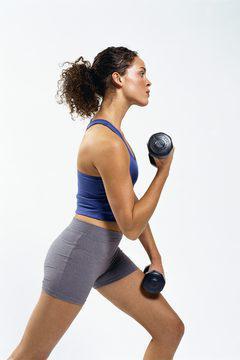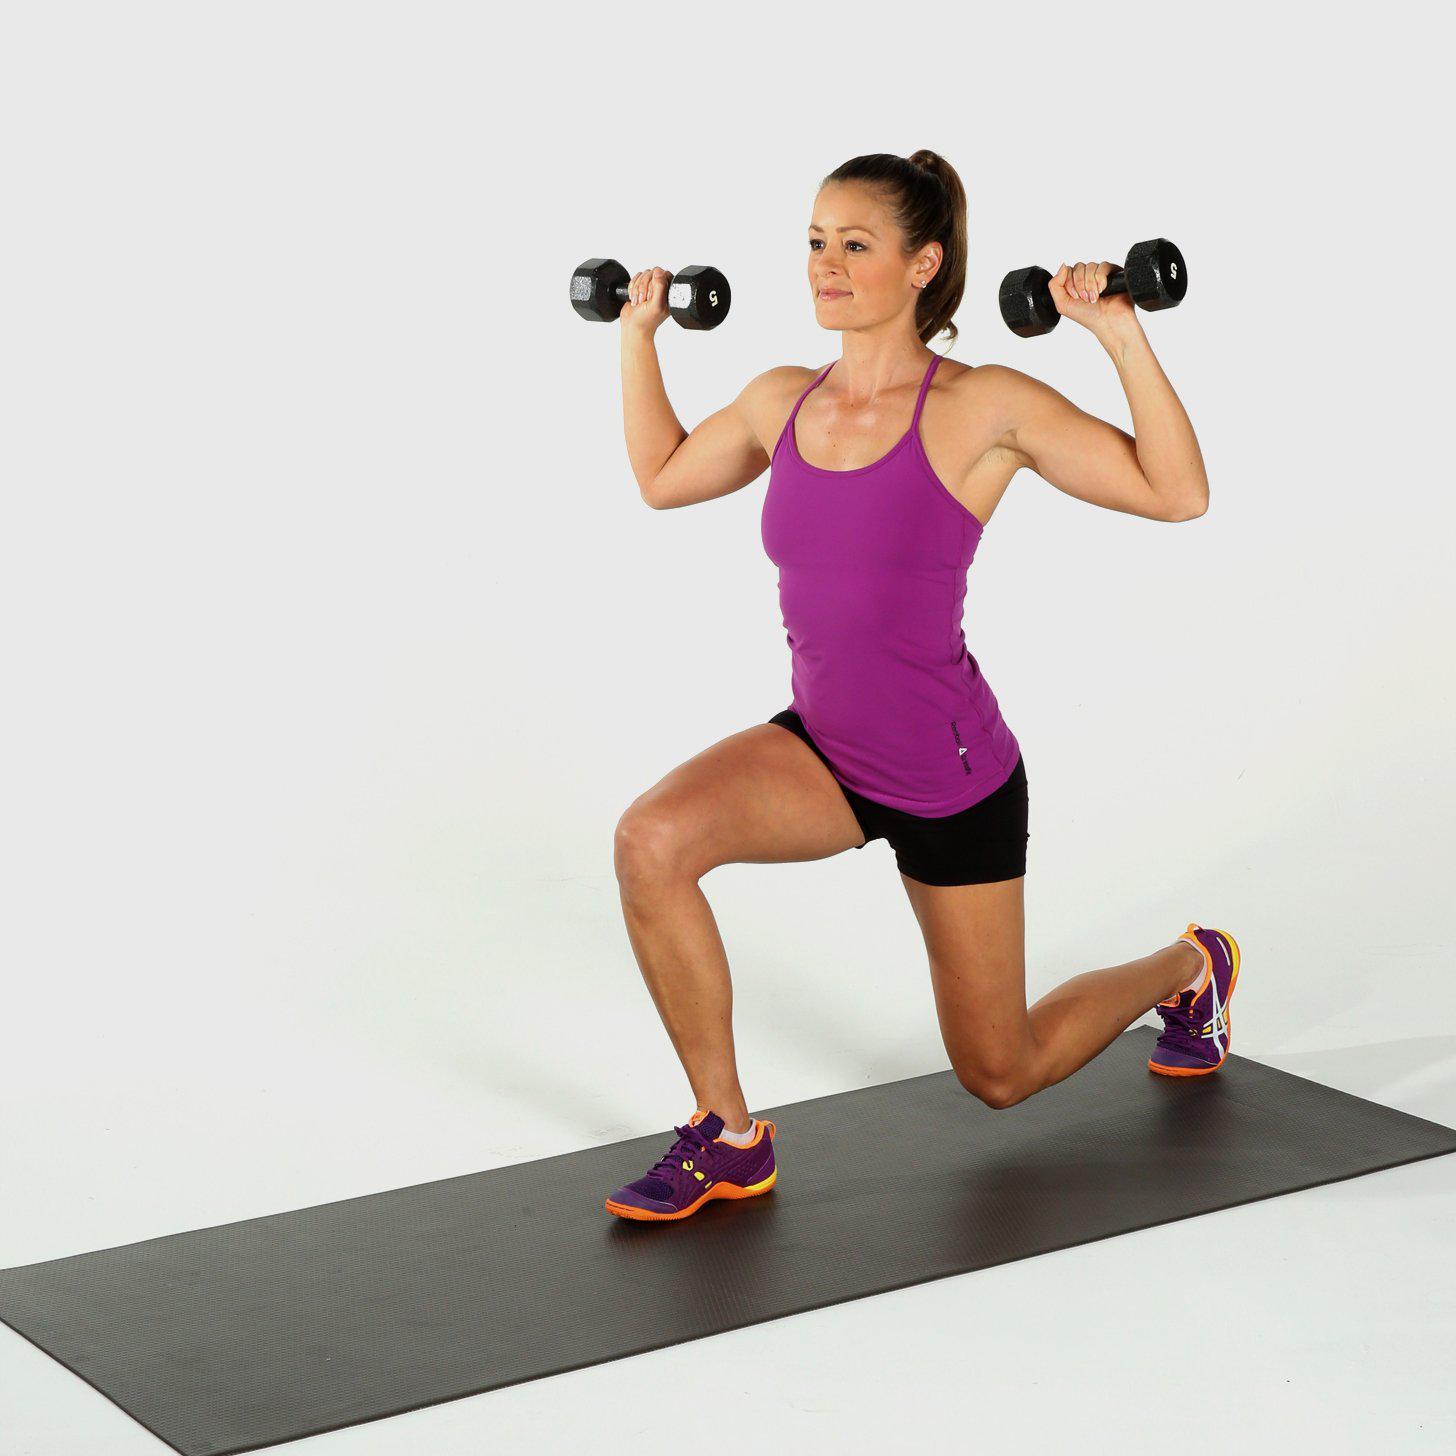The first image is the image on the left, the second image is the image on the right. Examine the images to the left and right. Is the description "A woman is in lunge position with weights down." accurate? Answer yes or no. No. The first image is the image on the left, the second image is the image on the right. For the images shown, is this caption "An image shows a girl in sports bra and short black shorts doing a lunge without a mat while holding dumbbells." true? Answer yes or no. No. 